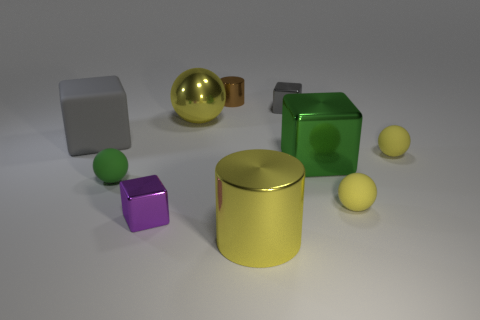Subtract all brown cylinders. How many yellow balls are left? 3 Subtract all spheres. How many objects are left? 6 Subtract all tiny gray metallic blocks. Subtract all small metallic blocks. How many objects are left? 7 Add 3 yellow metal balls. How many yellow metal balls are left? 4 Add 2 purple metallic cylinders. How many purple metallic cylinders exist? 2 Subtract 0 cyan balls. How many objects are left? 10 